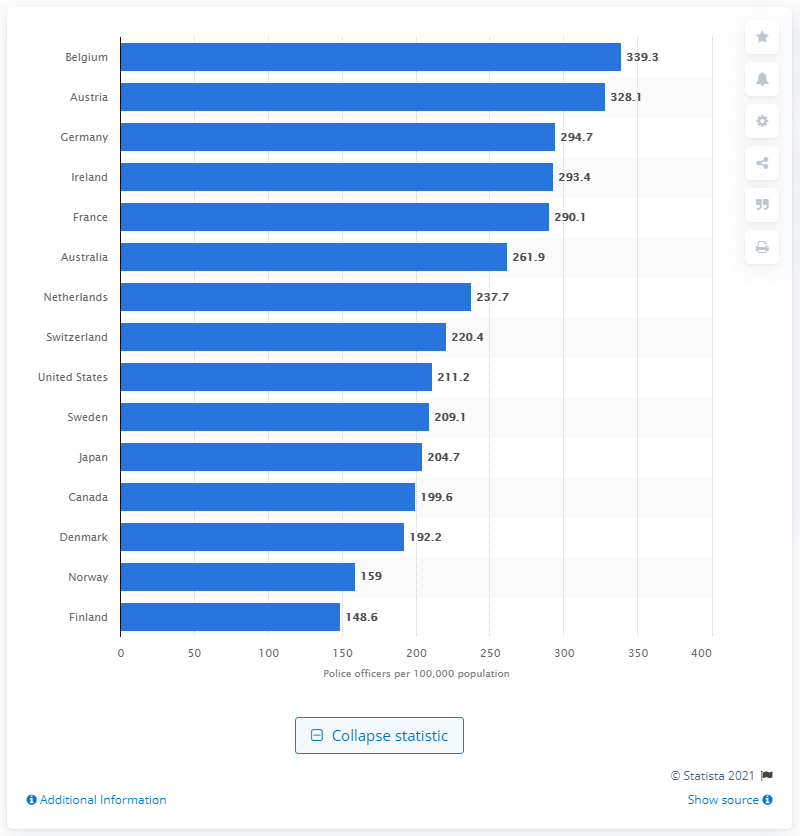Point out several critical features in this image. In 2012, there were 339.3 police officers for every 100,000 people in Belgium. 